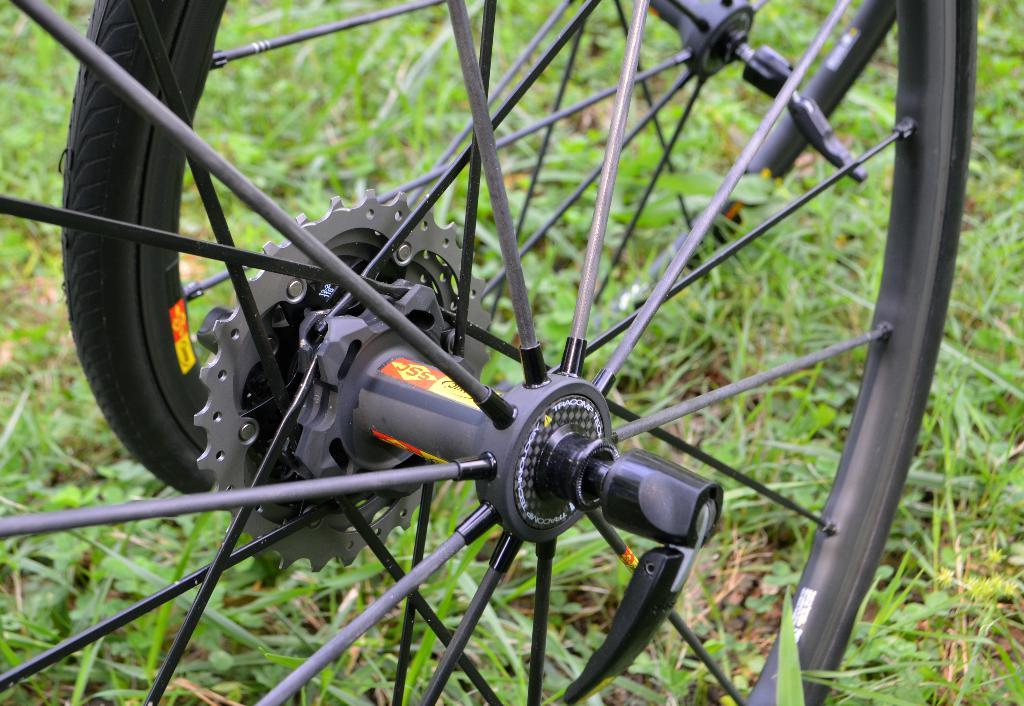What type of object has wheels in the image? The information provided does not specify what type of object has wheels in the image. What can be seen beneath the wheels in the image? The ground is visible in the image. What type of vegetation is present on the ground in the image? Grass is present on the ground in the image. What other type of plant can be seen in the image? There are plants in the image. What type of stew is being served in the image? There is no stew present in the image; it only features wheels, ground, grass, and plants. 